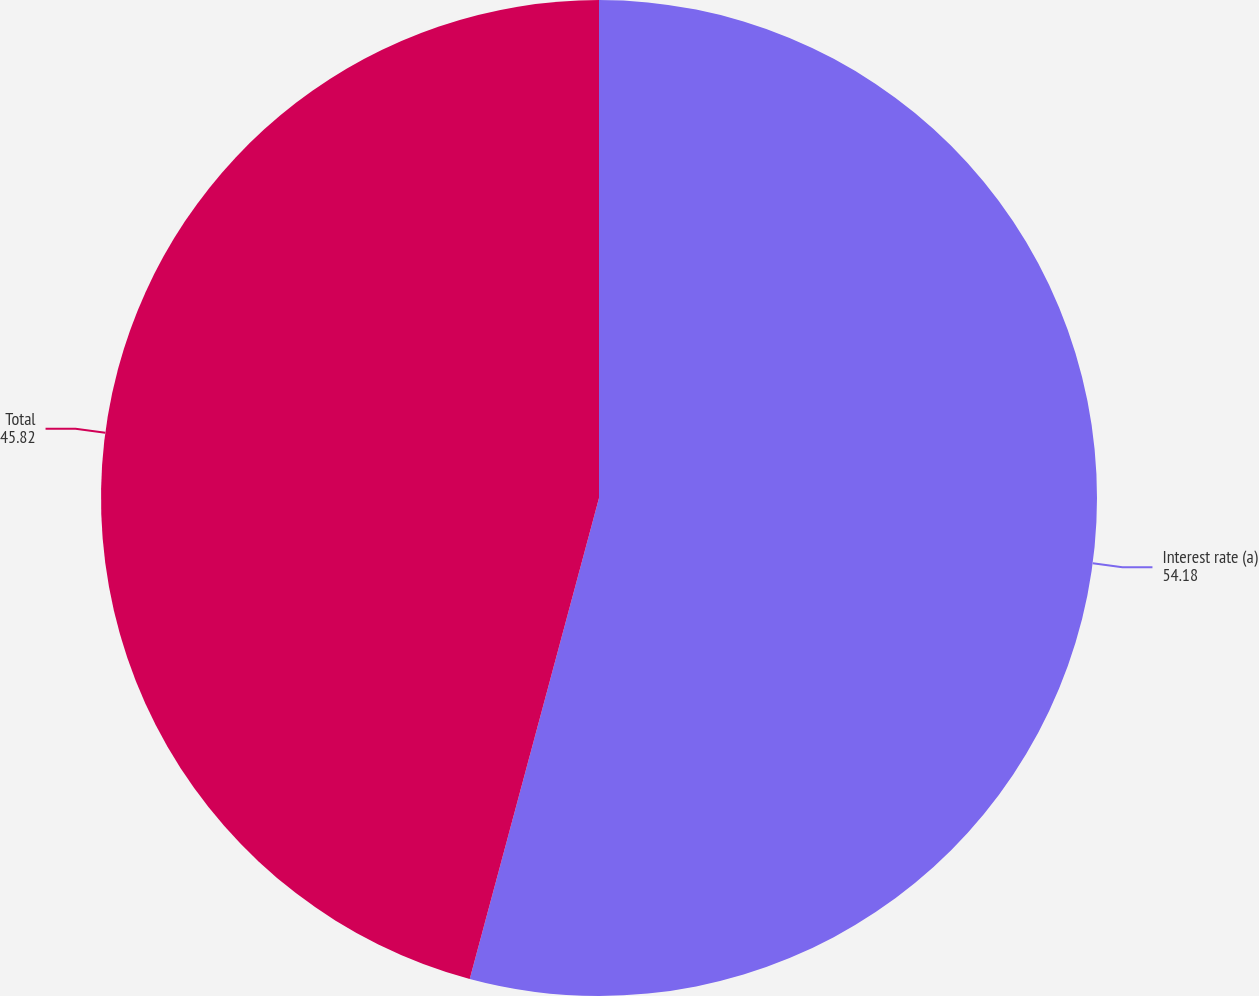Convert chart to OTSL. <chart><loc_0><loc_0><loc_500><loc_500><pie_chart><fcel>Interest rate (a)<fcel>Total<nl><fcel>54.18%<fcel>45.82%<nl></chart> 